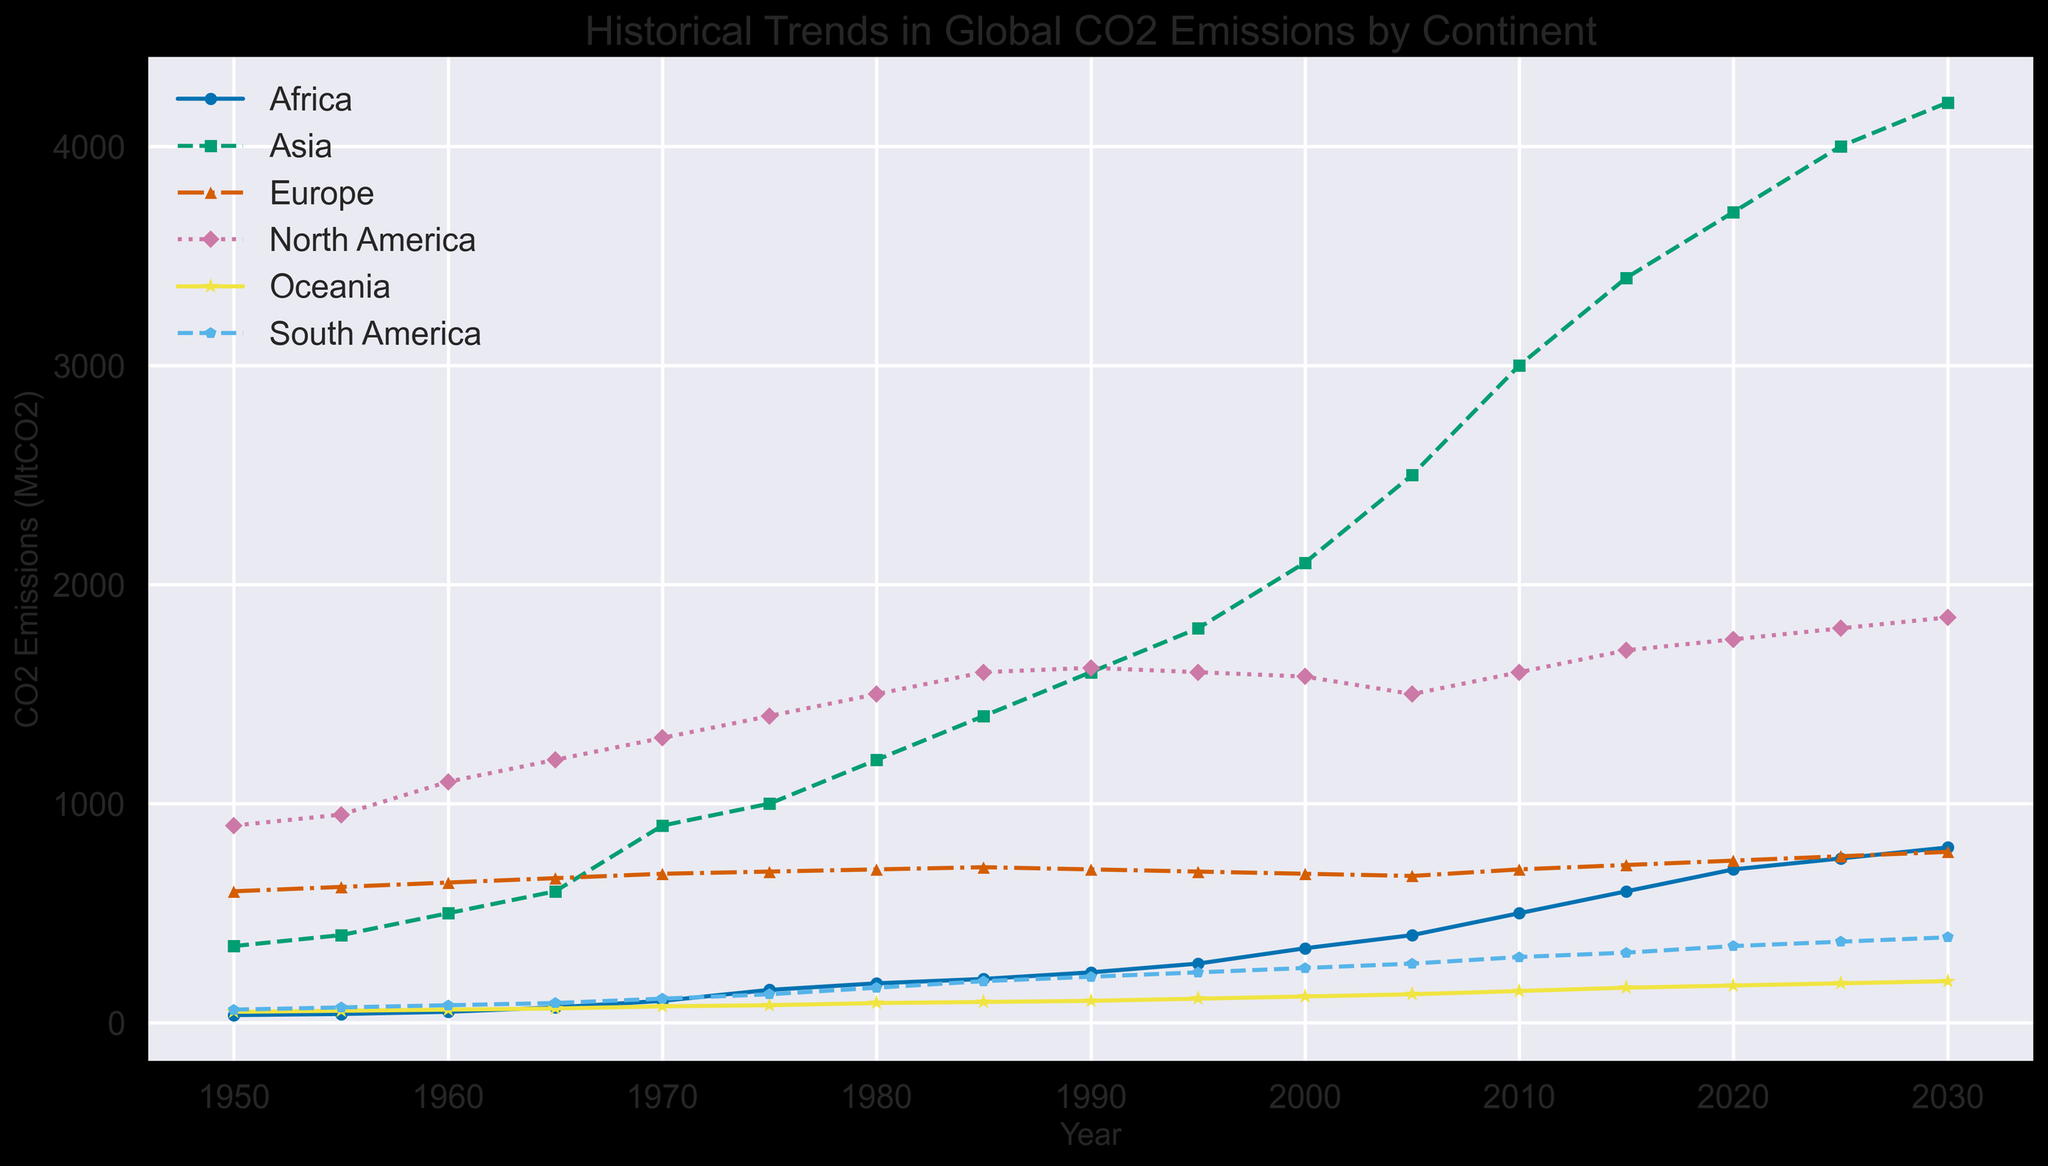Which continent has the highest CO2 emissions in 1970? From the figure, observe the line markers for 1970 and compare the values for each continent. Asia has the highest value.
Answer: Asia How did the CO2 emissions of Africa change from 1950 to 2020? Find the starting value for Africa in 1950, which is 35, and the ending value in 2020, which is 700. Calculate the change: 700 - 35 = 665.
Answer: Increased by 665 MtCO2 Between 1990 and 2000, which continent had a decrease in CO2 emissions? Analyze the lines for each continent between 1990 and 2000. Europe shows a decreasing trend from 700 to 680 MtCO2.
Answer: Europe In 2020, which continent had CO2 emissions closest to 2000 MtCO2? Compare the 2020 emissions values for all continents against 2000 MtCO2. North America is the closest with 1750 MtCO2.
Answer: North America What was the average CO2 emission for South America from 1990 to 2000? Find the values for South America in 1990 (210) and 2000 (250). Calculate the average: (210 + 250)/2 = 230.
Answer: 230 MtCO2 Which three continents showed continuous growth in CO2 emissions from 1950 to 2030? Examine the trend lines for each continent and identify those that consistently rise. Africa, Asia, and South America show continuous growth.
Answer: Africa, Asia, South America Between 2000 and 2025, how much did the CO2 emissions of Asia increase? Find the values for Asia in 2000 (2100) and 2025 (4000). Calculate the increase: 4000 - 2100 = 1900.
Answer: Increased by 1900 MtCO2 Did any continent have a periodic decrease in CO2 emissions within the given time frame? Review the trend lines for periods of decrease. Europe shows a periodic decrease, from 1990 to 2005.
Answer: Europe Which continent's CO2 emissions were consistently lower than Australia's (Oceania's) in the year 1980? Compare Oceania's 1980 emissions (90) with the emissions of other continents in the same year. South America consistently had lower emissions (160).
Answer: South America By how much did North America's CO2 emissions decrease from 1990 to 2005? Find the values for North America in 1990 (1620) and 2005 (1500). Calculate the decrease: 1620 - 1500 = 120.
Answer: Decreased by 120 MtCO2 